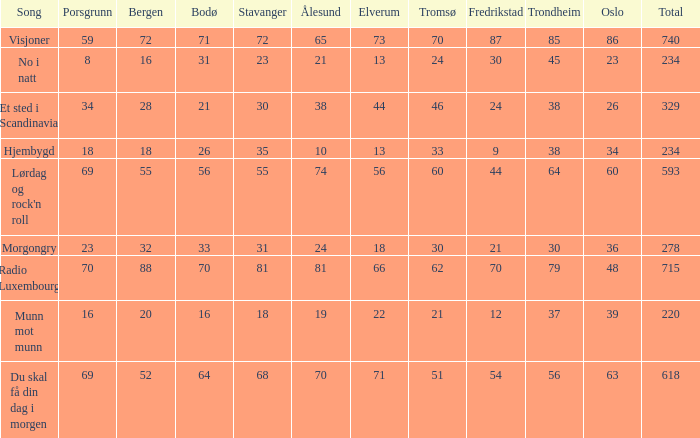How many elverum are tehre for et sted i scandinavia? 1.0. 